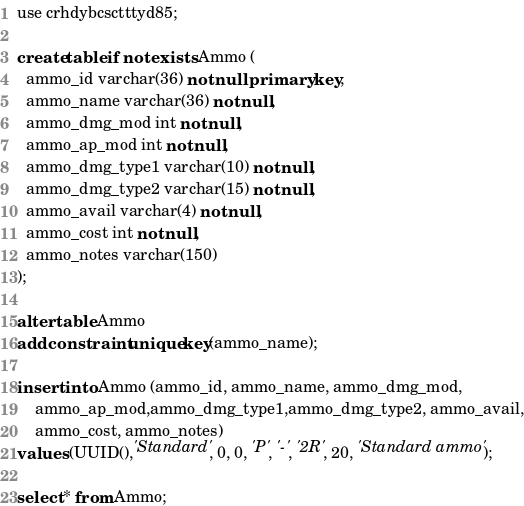Convert code to text. <code><loc_0><loc_0><loc_500><loc_500><_SQL_>use crhdybcsctttyd85;

create table if not exists Ammo (
  ammo_id varchar(36) not null primary key,
  ammo_name varchar(36) not null,
  ammo_dmg_mod int not null,
  ammo_ap_mod int not null,
  ammo_dmg_type1 varchar(10) not null,
  ammo_dmg_type2 varchar(15) not null,
  ammo_avail varchar(4) not null,
  ammo_cost int not null,
  ammo_notes varchar(150)
);

alter table Ammo 
add constraint unique key(ammo_name);

insert into Ammo (ammo_id, ammo_name, ammo_dmg_mod,
    ammo_ap_mod,ammo_dmg_type1,ammo_dmg_type2, ammo_avail,
    ammo_cost, ammo_notes)
values (UUID(),'Standard', 0, 0, 'P', '-', '2R', 20, 'Standard ammo');

select * from Ammo;</code> 